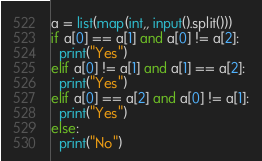Convert code to text. <code><loc_0><loc_0><loc_500><loc_500><_Python_>a = list(map(int,, input().split()))
if a[0] == a[1] and a[0] != a[2]:
  print("Yes")
elif a[0] != a[1] and a[1] == a[2]:
  print("Yes")
elif a[0] == a[2] and a[0] != a[1]:
  print("Yes")
else:
  print("No")</code> 